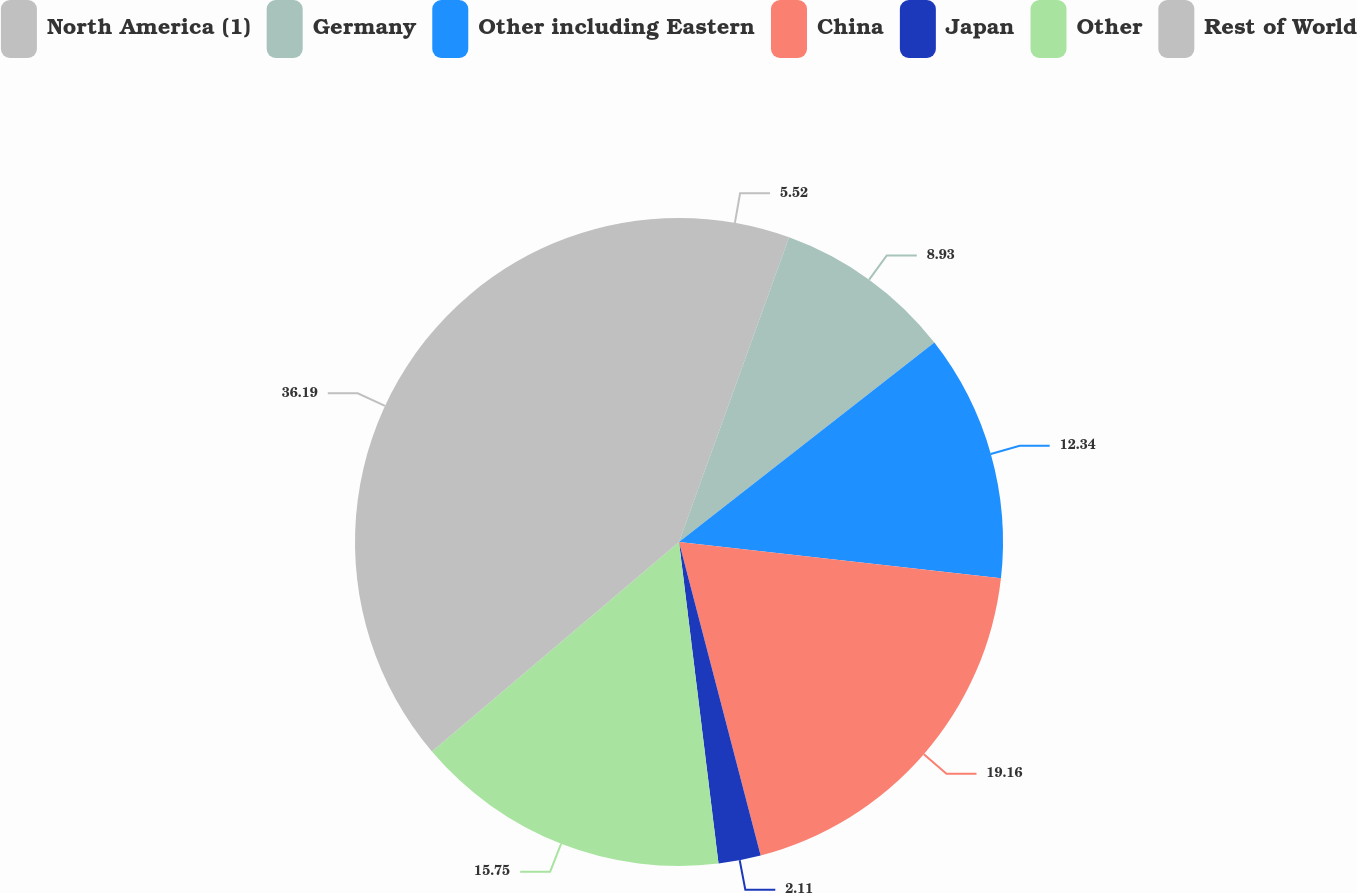<chart> <loc_0><loc_0><loc_500><loc_500><pie_chart><fcel>North America (1)<fcel>Germany<fcel>Other including Eastern<fcel>China<fcel>Japan<fcel>Other<fcel>Rest of World<nl><fcel>5.52%<fcel>8.93%<fcel>12.34%<fcel>19.16%<fcel>2.11%<fcel>15.75%<fcel>36.2%<nl></chart> 